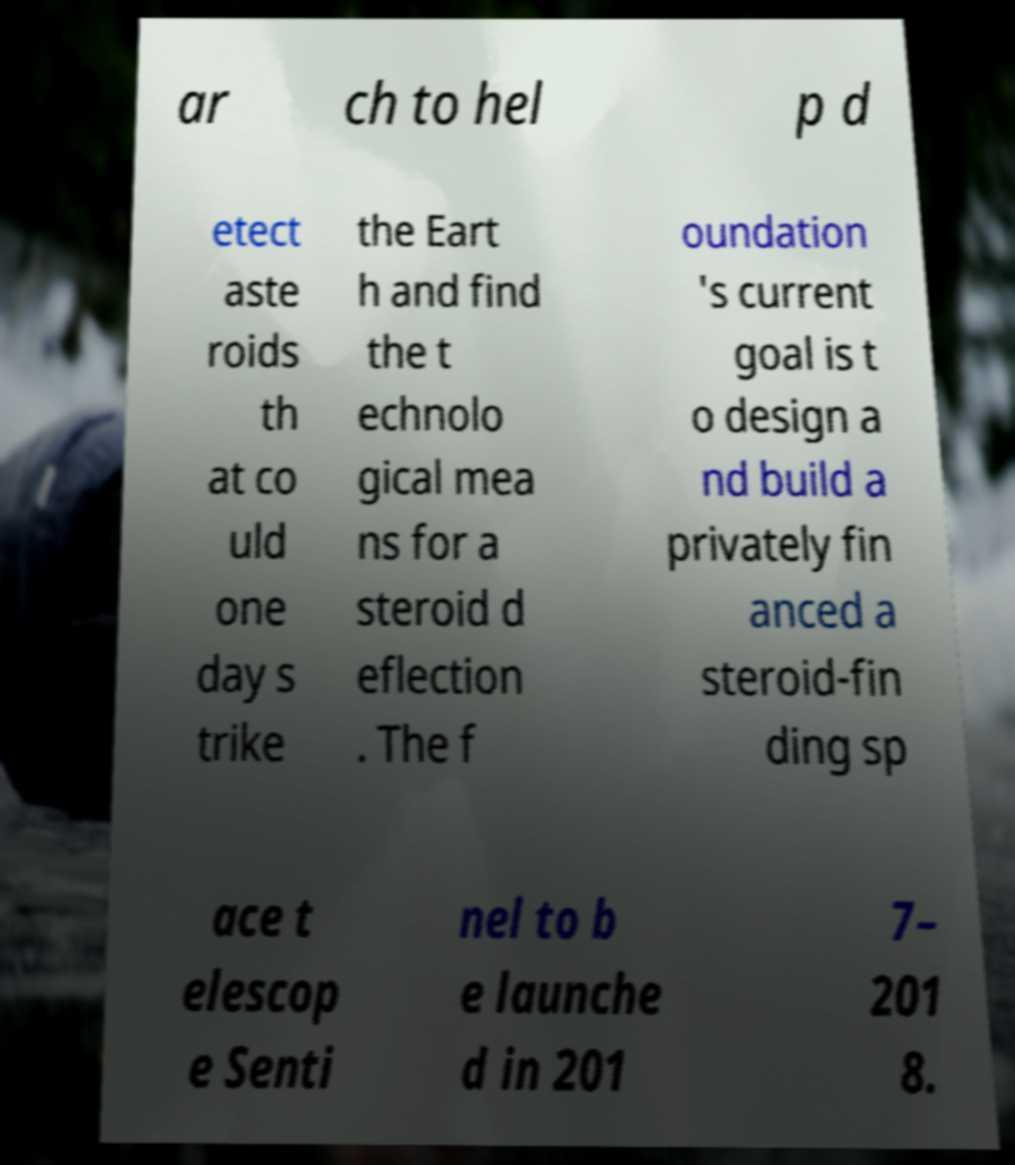There's text embedded in this image that I need extracted. Can you transcribe it verbatim? ar ch to hel p d etect aste roids th at co uld one day s trike the Eart h and find the t echnolo gical mea ns for a steroid d eflection . The f oundation 's current goal is t o design a nd build a privately fin anced a steroid-fin ding sp ace t elescop e Senti nel to b e launche d in 201 7– 201 8. 